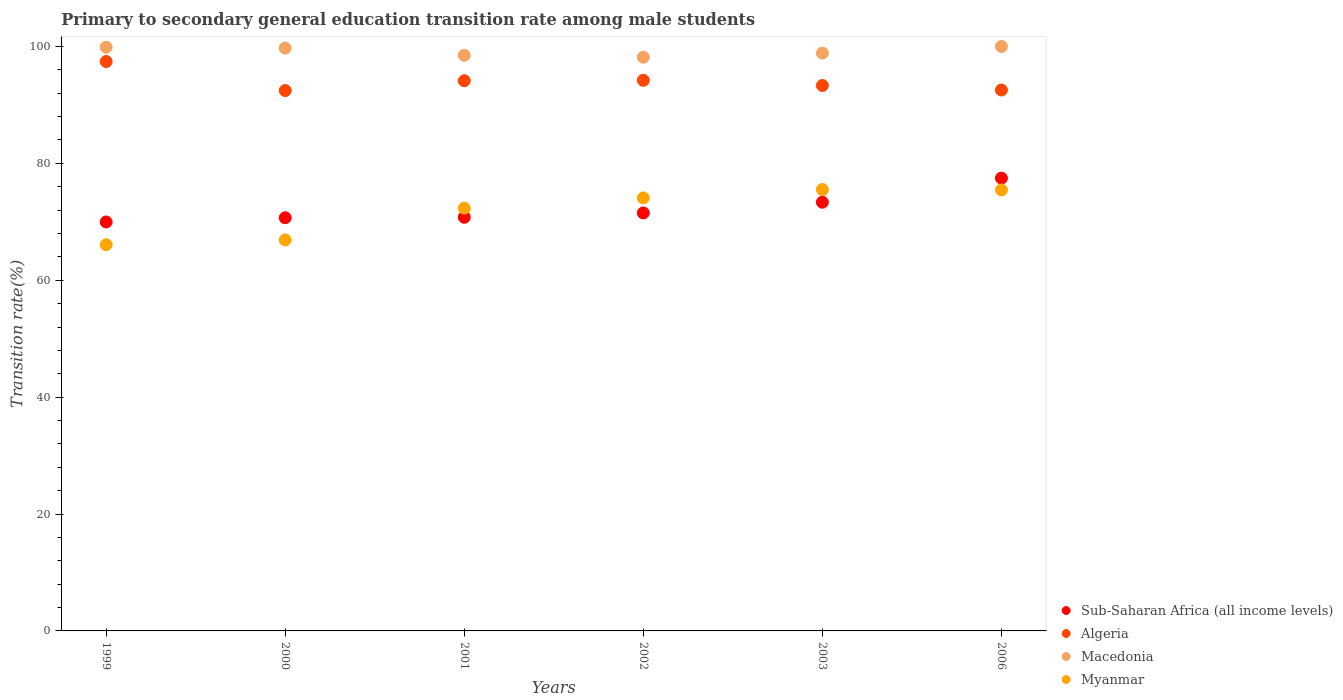Is the number of dotlines equal to the number of legend labels?
Keep it short and to the point. Yes. What is the transition rate in Algeria in 2000?
Ensure brevity in your answer.  92.46. Across all years, what is the maximum transition rate in Algeria?
Provide a succinct answer. 97.42. Across all years, what is the minimum transition rate in Algeria?
Provide a short and direct response. 92.46. What is the total transition rate in Myanmar in the graph?
Your answer should be compact. 430.37. What is the difference between the transition rate in Myanmar in 1999 and that in 2001?
Your answer should be compact. -6.25. What is the difference between the transition rate in Sub-Saharan Africa (all income levels) in 2006 and the transition rate in Myanmar in 2001?
Offer a terse response. 5.15. What is the average transition rate in Macedonia per year?
Provide a short and direct response. 99.19. In the year 2002, what is the difference between the transition rate in Macedonia and transition rate in Myanmar?
Keep it short and to the point. 24.08. What is the ratio of the transition rate in Macedonia in 2000 to that in 2003?
Ensure brevity in your answer.  1.01. Is the transition rate in Myanmar in 2001 less than that in 2002?
Your response must be concise. Yes. Is the difference between the transition rate in Macedonia in 1999 and 2003 greater than the difference between the transition rate in Myanmar in 1999 and 2003?
Offer a terse response. Yes. What is the difference between the highest and the second highest transition rate in Algeria?
Offer a very short reply. 3.21. What is the difference between the highest and the lowest transition rate in Myanmar?
Ensure brevity in your answer.  9.45. In how many years, is the transition rate in Macedonia greater than the average transition rate in Macedonia taken over all years?
Your answer should be very brief. 3. Is the sum of the transition rate in Macedonia in 2003 and 2006 greater than the maximum transition rate in Algeria across all years?
Your answer should be compact. Yes. Is the transition rate in Macedonia strictly greater than the transition rate in Myanmar over the years?
Make the answer very short. Yes. Is the transition rate in Myanmar strictly less than the transition rate in Macedonia over the years?
Offer a very short reply. Yes. Are the values on the major ticks of Y-axis written in scientific E-notation?
Your response must be concise. No. How many legend labels are there?
Offer a very short reply. 4. How are the legend labels stacked?
Ensure brevity in your answer.  Vertical. What is the title of the graph?
Keep it short and to the point. Primary to secondary general education transition rate among male students. What is the label or title of the Y-axis?
Give a very brief answer. Transition rate(%). What is the Transition rate(%) in Sub-Saharan Africa (all income levels) in 1999?
Your answer should be compact. 69.97. What is the Transition rate(%) of Algeria in 1999?
Your answer should be very brief. 97.42. What is the Transition rate(%) of Macedonia in 1999?
Your answer should be very brief. 99.87. What is the Transition rate(%) of Myanmar in 1999?
Your response must be concise. 66.07. What is the Transition rate(%) in Sub-Saharan Africa (all income levels) in 2000?
Your answer should be very brief. 70.7. What is the Transition rate(%) in Algeria in 2000?
Your answer should be very brief. 92.46. What is the Transition rate(%) in Macedonia in 2000?
Make the answer very short. 99.73. What is the Transition rate(%) of Myanmar in 2000?
Your answer should be compact. 66.9. What is the Transition rate(%) of Sub-Saharan Africa (all income levels) in 2001?
Give a very brief answer. 70.78. What is the Transition rate(%) in Algeria in 2001?
Provide a short and direct response. 94.14. What is the Transition rate(%) in Macedonia in 2001?
Ensure brevity in your answer.  98.49. What is the Transition rate(%) in Myanmar in 2001?
Your answer should be very brief. 72.33. What is the Transition rate(%) of Sub-Saharan Africa (all income levels) in 2002?
Your answer should be very brief. 71.52. What is the Transition rate(%) in Algeria in 2002?
Make the answer very short. 94.22. What is the Transition rate(%) of Macedonia in 2002?
Provide a succinct answer. 98.17. What is the Transition rate(%) in Myanmar in 2002?
Your answer should be very brief. 74.09. What is the Transition rate(%) in Sub-Saharan Africa (all income levels) in 2003?
Your answer should be very brief. 73.36. What is the Transition rate(%) of Algeria in 2003?
Ensure brevity in your answer.  93.33. What is the Transition rate(%) of Macedonia in 2003?
Keep it short and to the point. 98.87. What is the Transition rate(%) in Myanmar in 2003?
Make the answer very short. 75.52. What is the Transition rate(%) of Sub-Saharan Africa (all income levels) in 2006?
Provide a succinct answer. 77.47. What is the Transition rate(%) of Algeria in 2006?
Make the answer very short. 92.56. What is the Transition rate(%) of Myanmar in 2006?
Ensure brevity in your answer.  75.45. Across all years, what is the maximum Transition rate(%) of Sub-Saharan Africa (all income levels)?
Offer a very short reply. 77.47. Across all years, what is the maximum Transition rate(%) of Algeria?
Your answer should be very brief. 97.42. Across all years, what is the maximum Transition rate(%) of Macedonia?
Offer a terse response. 100. Across all years, what is the maximum Transition rate(%) of Myanmar?
Ensure brevity in your answer.  75.52. Across all years, what is the minimum Transition rate(%) in Sub-Saharan Africa (all income levels)?
Provide a short and direct response. 69.97. Across all years, what is the minimum Transition rate(%) of Algeria?
Provide a succinct answer. 92.46. Across all years, what is the minimum Transition rate(%) of Macedonia?
Provide a succinct answer. 98.17. Across all years, what is the minimum Transition rate(%) of Myanmar?
Make the answer very short. 66.07. What is the total Transition rate(%) in Sub-Saharan Africa (all income levels) in the graph?
Ensure brevity in your answer.  433.8. What is the total Transition rate(%) in Algeria in the graph?
Provide a short and direct response. 564.13. What is the total Transition rate(%) in Macedonia in the graph?
Keep it short and to the point. 595.13. What is the total Transition rate(%) of Myanmar in the graph?
Provide a short and direct response. 430.37. What is the difference between the Transition rate(%) in Sub-Saharan Africa (all income levels) in 1999 and that in 2000?
Ensure brevity in your answer.  -0.72. What is the difference between the Transition rate(%) of Algeria in 1999 and that in 2000?
Your answer should be very brief. 4.96. What is the difference between the Transition rate(%) of Macedonia in 1999 and that in 2000?
Offer a terse response. 0.15. What is the difference between the Transition rate(%) of Myanmar in 1999 and that in 2000?
Provide a succinct answer. -0.83. What is the difference between the Transition rate(%) in Sub-Saharan Africa (all income levels) in 1999 and that in 2001?
Provide a short and direct response. -0.8. What is the difference between the Transition rate(%) in Algeria in 1999 and that in 2001?
Offer a very short reply. 3.28. What is the difference between the Transition rate(%) of Macedonia in 1999 and that in 2001?
Your response must be concise. 1.38. What is the difference between the Transition rate(%) of Myanmar in 1999 and that in 2001?
Ensure brevity in your answer.  -6.25. What is the difference between the Transition rate(%) of Sub-Saharan Africa (all income levels) in 1999 and that in 2002?
Provide a short and direct response. -1.54. What is the difference between the Transition rate(%) of Algeria in 1999 and that in 2002?
Ensure brevity in your answer.  3.21. What is the difference between the Transition rate(%) in Macedonia in 1999 and that in 2002?
Give a very brief answer. 1.7. What is the difference between the Transition rate(%) in Myanmar in 1999 and that in 2002?
Give a very brief answer. -8.02. What is the difference between the Transition rate(%) in Sub-Saharan Africa (all income levels) in 1999 and that in 2003?
Provide a short and direct response. -3.38. What is the difference between the Transition rate(%) in Algeria in 1999 and that in 2003?
Your answer should be very brief. 4.1. What is the difference between the Transition rate(%) of Macedonia in 1999 and that in 2003?
Give a very brief answer. 1.01. What is the difference between the Transition rate(%) of Myanmar in 1999 and that in 2003?
Make the answer very short. -9.45. What is the difference between the Transition rate(%) of Sub-Saharan Africa (all income levels) in 1999 and that in 2006?
Provide a succinct answer. -7.5. What is the difference between the Transition rate(%) in Algeria in 1999 and that in 2006?
Give a very brief answer. 4.87. What is the difference between the Transition rate(%) of Macedonia in 1999 and that in 2006?
Give a very brief answer. -0.13. What is the difference between the Transition rate(%) of Myanmar in 1999 and that in 2006?
Ensure brevity in your answer.  -9.38. What is the difference between the Transition rate(%) in Sub-Saharan Africa (all income levels) in 2000 and that in 2001?
Provide a succinct answer. -0.08. What is the difference between the Transition rate(%) in Algeria in 2000 and that in 2001?
Your response must be concise. -1.68. What is the difference between the Transition rate(%) of Macedonia in 2000 and that in 2001?
Offer a very short reply. 1.24. What is the difference between the Transition rate(%) in Myanmar in 2000 and that in 2001?
Offer a very short reply. -5.43. What is the difference between the Transition rate(%) in Sub-Saharan Africa (all income levels) in 2000 and that in 2002?
Provide a succinct answer. -0.82. What is the difference between the Transition rate(%) in Algeria in 2000 and that in 2002?
Your answer should be compact. -1.75. What is the difference between the Transition rate(%) in Macedonia in 2000 and that in 2002?
Keep it short and to the point. 1.56. What is the difference between the Transition rate(%) in Myanmar in 2000 and that in 2002?
Offer a very short reply. -7.19. What is the difference between the Transition rate(%) of Sub-Saharan Africa (all income levels) in 2000 and that in 2003?
Ensure brevity in your answer.  -2.66. What is the difference between the Transition rate(%) of Algeria in 2000 and that in 2003?
Offer a terse response. -0.87. What is the difference between the Transition rate(%) of Macedonia in 2000 and that in 2003?
Make the answer very short. 0.86. What is the difference between the Transition rate(%) of Myanmar in 2000 and that in 2003?
Provide a short and direct response. -8.62. What is the difference between the Transition rate(%) in Sub-Saharan Africa (all income levels) in 2000 and that in 2006?
Provide a short and direct response. -6.78. What is the difference between the Transition rate(%) in Algeria in 2000 and that in 2006?
Keep it short and to the point. -0.1. What is the difference between the Transition rate(%) of Macedonia in 2000 and that in 2006?
Offer a very short reply. -0.27. What is the difference between the Transition rate(%) in Myanmar in 2000 and that in 2006?
Offer a terse response. -8.55. What is the difference between the Transition rate(%) of Sub-Saharan Africa (all income levels) in 2001 and that in 2002?
Provide a succinct answer. -0.74. What is the difference between the Transition rate(%) in Algeria in 2001 and that in 2002?
Your response must be concise. -0.07. What is the difference between the Transition rate(%) of Macedonia in 2001 and that in 2002?
Your response must be concise. 0.32. What is the difference between the Transition rate(%) of Myanmar in 2001 and that in 2002?
Give a very brief answer. -1.76. What is the difference between the Transition rate(%) of Sub-Saharan Africa (all income levels) in 2001 and that in 2003?
Make the answer very short. -2.58. What is the difference between the Transition rate(%) of Algeria in 2001 and that in 2003?
Keep it short and to the point. 0.81. What is the difference between the Transition rate(%) of Macedonia in 2001 and that in 2003?
Offer a very short reply. -0.37. What is the difference between the Transition rate(%) in Myanmar in 2001 and that in 2003?
Ensure brevity in your answer.  -3.19. What is the difference between the Transition rate(%) in Sub-Saharan Africa (all income levels) in 2001 and that in 2006?
Your response must be concise. -6.7. What is the difference between the Transition rate(%) of Algeria in 2001 and that in 2006?
Provide a succinct answer. 1.58. What is the difference between the Transition rate(%) of Macedonia in 2001 and that in 2006?
Give a very brief answer. -1.51. What is the difference between the Transition rate(%) in Myanmar in 2001 and that in 2006?
Provide a succinct answer. -3.12. What is the difference between the Transition rate(%) in Sub-Saharan Africa (all income levels) in 2002 and that in 2003?
Offer a very short reply. -1.84. What is the difference between the Transition rate(%) in Algeria in 2002 and that in 2003?
Your answer should be very brief. 0.89. What is the difference between the Transition rate(%) of Macedonia in 2002 and that in 2003?
Your response must be concise. -0.7. What is the difference between the Transition rate(%) of Myanmar in 2002 and that in 2003?
Provide a succinct answer. -1.43. What is the difference between the Transition rate(%) of Sub-Saharan Africa (all income levels) in 2002 and that in 2006?
Offer a very short reply. -5.96. What is the difference between the Transition rate(%) in Algeria in 2002 and that in 2006?
Your answer should be compact. 1.66. What is the difference between the Transition rate(%) in Macedonia in 2002 and that in 2006?
Your answer should be compact. -1.83. What is the difference between the Transition rate(%) in Myanmar in 2002 and that in 2006?
Your answer should be very brief. -1.36. What is the difference between the Transition rate(%) in Sub-Saharan Africa (all income levels) in 2003 and that in 2006?
Ensure brevity in your answer.  -4.12. What is the difference between the Transition rate(%) in Algeria in 2003 and that in 2006?
Offer a very short reply. 0.77. What is the difference between the Transition rate(%) in Macedonia in 2003 and that in 2006?
Your response must be concise. -1.13. What is the difference between the Transition rate(%) of Myanmar in 2003 and that in 2006?
Offer a very short reply. 0.07. What is the difference between the Transition rate(%) in Sub-Saharan Africa (all income levels) in 1999 and the Transition rate(%) in Algeria in 2000?
Offer a very short reply. -22.49. What is the difference between the Transition rate(%) of Sub-Saharan Africa (all income levels) in 1999 and the Transition rate(%) of Macedonia in 2000?
Offer a very short reply. -29.75. What is the difference between the Transition rate(%) in Sub-Saharan Africa (all income levels) in 1999 and the Transition rate(%) in Myanmar in 2000?
Keep it short and to the point. 3.07. What is the difference between the Transition rate(%) in Algeria in 1999 and the Transition rate(%) in Macedonia in 2000?
Provide a short and direct response. -2.3. What is the difference between the Transition rate(%) of Algeria in 1999 and the Transition rate(%) of Myanmar in 2000?
Provide a short and direct response. 30.52. What is the difference between the Transition rate(%) in Macedonia in 1999 and the Transition rate(%) in Myanmar in 2000?
Offer a terse response. 32.97. What is the difference between the Transition rate(%) in Sub-Saharan Africa (all income levels) in 1999 and the Transition rate(%) in Algeria in 2001?
Provide a succinct answer. -24.17. What is the difference between the Transition rate(%) in Sub-Saharan Africa (all income levels) in 1999 and the Transition rate(%) in Macedonia in 2001?
Your answer should be very brief. -28.52. What is the difference between the Transition rate(%) in Sub-Saharan Africa (all income levels) in 1999 and the Transition rate(%) in Myanmar in 2001?
Your response must be concise. -2.35. What is the difference between the Transition rate(%) in Algeria in 1999 and the Transition rate(%) in Macedonia in 2001?
Offer a very short reply. -1.07. What is the difference between the Transition rate(%) of Algeria in 1999 and the Transition rate(%) of Myanmar in 2001?
Give a very brief answer. 25.1. What is the difference between the Transition rate(%) in Macedonia in 1999 and the Transition rate(%) in Myanmar in 2001?
Keep it short and to the point. 27.55. What is the difference between the Transition rate(%) in Sub-Saharan Africa (all income levels) in 1999 and the Transition rate(%) in Algeria in 2002?
Your response must be concise. -24.24. What is the difference between the Transition rate(%) of Sub-Saharan Africa (all income levels) in 1999 and the Transition rate(%) of Macedonia in 2002?
Keep it short and to the point. -28.2. What is the difference between the Transition rate(%) in Sub-Saharan Africa (all income levels) in 1999 and the Transition rate(%) in Myanmar in 2002?
Your answer should be very brief. -4.12. What is the difference between the Transition rate(%) in Algeria in 1999 and the Transition rate(%) in Macedonia in 2002?
Ensure brevity in your answer.  -0.75. What is the difference between the Transition rate(%) in Algeria in 1999 and the Transition rate(%) in Myanmar in 2002?
Give a very brief answer. 23.33. What is the difference between the Transition rate(%) of Macedonia in 1999 and the Transition rate(%) of Myanmar in 2002?
Keep it short and to the point. 25.78. What is the difference between the Transition rate(%) of Sub-Saharan Africa (all income levels) in 1999 and the Transition rate(%) of Algeria in 2003?
Ensure brevity in your answer.  -23.35. What is the difference between the Transition rate(%) in Sub-Saharan Africa (all income levels) in 1999 and the Transition rate(%) in Macedonia in 2003?
Provide a succinct answer. -28.89. What is the difference between the Transition rate(%) in Sub-Saharan Africa (all income levels) in 1999 and the Transition rate(%) in Myanmar in 2003?
Your answer should be compact. -5.55. What is the difference between the Transition rate(%) in Algeria in 1999 and the Transition rate(%) in Macedonia in 2003?
Provide a short and direct response. -1.44. What is the difference between the Transition rate(%) of Algeria in 1999 and the Transition rate(%) of Myanmar in 2003?
Your answer should be very brief. 21.9. What is the difference between the Transition rate(%) of Macedonia in 1999 and the Transition rate(%) of Myanmar in 2003?
Your answer should be compact. 24.35. What is the difference between the Transition rate(%) in Sub-Saharan Africa (all income levels) in 1999 and the Transition rate(%) in Algeria in 2006?
Keep it short and to the point. -22.58. What is the difference between the Transition rate(%) of Sub-Saharan Africa (all income levels) in 1999 and the Transition rate(%) of Macedonia in 2006?
Offer a terse response. -30.03. What is the difference between the Transition rate(%) in Sub-Saharan Africa (all income levels) in 1999 and the Transition rate(%) in Myanmar in 2006?
Ensure brevity in your answer.  -5.48. What is the difference between the Transition rate(%) of Algeria in 1999 and the Transition rate(%) of Macedonia in 2006?
Your answer should be very brief. -2.58. What is the difference between the Transition rate(%) of Algeria in 1999 and the Transition rate(%) of Myanmar in 2006?
Offer a terse response. 21.97. What is the difference between the Transition rate(%) of Macedonia in 1999 and the Transition rate(%) of Myanmar in 2006?
Your response must be concise. 24.42. What is the difference between the Transition rate(%) in Sub-Saharan Africa (all income levels) in 2000 and the Transition rate(%) in Algeria in 2001?
Provide a succinct answer. -23.44. What is the difference between the Transition rate(%) of Sub-Saharan Africa (all income levels) in 2000 and the Transition rate(%) of Macedonia in 2001?
Ensure brevity in your answer.  -27.79. What is the difference between the Transition rate(%) in Sub-Saharan Africa (all income levels) in 2000 and the Transition rate(%) in Myanmar in 2001?
Offer a terse response. -1.63. What is the difference between the Transition rate(%) of Algeria in 2000 and the Transition rate(%) of Macedonia in 2001?
Your answer should be very brief. -6.03. What is the difference between the Transition rate(%) of Algeria in 2000 and the Transition rate(%) of Myanmar in 2001?
Ensure brevity in your answer.  20.13. What is the difference between the Transition rate(%) of Macedonia in 2000 and the Transition rate(%) of Myanmar in 2001?
Give a very brief answer. 27.4. What is the difference between the Transition rate(%) in Sub-Saharan Africa (all income levels) in 2000 and the Transition rate(%) in Algeria in 2002?
Offer a very short reply. -23.52. What is the difference between the Transition rate(%) of Sub-Saharan Africa (all income levels) in 2000 and the Transition rate(%) of Macedonia in 2002?
Give a very brief answer. -27.47. What is the difference between the Transition rate(%) in Sub-Saharan Africa (all income levels) in 2000 and the Transition rate(%) in Myanmar in 2002?
Give a very brief answer. -3.39. What is the difference between the Transition rate(%) in Algeria in 2000 and the Transition rate(%) in Macedonia in 2002?
Offer a terse response. -5.71. What is the difference between the Transition rate(%) in Algeria in 2000 and the Transition rate(%) in Myanmar in 2002?
Ensure brevity in your answer.  18.37. What is the difference between the Transition rate(%) of Macedonia in 2000 and the Transition rate(%) of Myanmar in 2002?
Your response must be concise. 25.64. What is the difference between the Transition rate(%) in Sub-Saharan Africa (all income levels) in 2000 and the Transition rate(%) in Algeria in 2003?
Provide a succinct answer. -22.63. What is the difference between the Transition rate(%) in Sub-Saharan Africa (all income levels) in 2000 and the Transition rate(%) in Macedonia in 2003?
Provide a succinct answer. -28.17. What is the difference between the Transition rate(%) of Sub-Saharan Africa (all income levels) in 2000 and the Transition rate(%) of Myanmar in 2003?
Provide a succinct answer. -4.83. What is the difference between the Transition rate(%) of Algeria in 2000 and the Transition rate(%) of Macedonia in 2003?
Offer a terse response. -6.4. What is the difference between the Transition rate(%) in Algeria in 2000 and the Transition rate(%) in Myanmar in 2003?
Your response must be concise. 16.94. What is the difference between the Transition rate(%) in Macedonia in 2000 and the Transition rate(%) in Myanmar in 2003?
Your answer should be compact. 24.2. What is the difference between the Transition rate(%) of Sub-Saharan Africa (all income levels) in 2000 and the Transition rate(%) of Algeria in 2006?
Provide a short and direct response. -21.86. What is the difference between the Transition rate(%) of Sub-Saharan Africa (all income levels) in 2000 and the Transition rate(%) of Macedonia in 2006?
Give a very brief answer. -29.3. What is the difference between the Transition rate(%) in Sub-Saharan Africa (all income levels) in 2000 and the Transition rate(%) in Myanmar in 2006?
Ensure brevity in your answer.  -4.75. What is the difference between the Transition rate(%) in Algeria in 2000 and the Transition rate(%) in Macedonia in 2006?
Offer a terse response. -7.54. What is the difference between the Transition rate(%) in Algeria in 2000 and the Transition rate(%) in Myanmar in 2006?
Keep it short and to the point. 17.01. What is the difference between the Transition rate(%) of Macedonia in 2000 and the Transition rate(%) of Myanmar in 2006?
Offer a very short reply. 24.28. What is the difference between the Transition rate(%) of Sub-Saharan Africa (all income levels) in 2001 and the Transition rate(%) of Algeria in 2002?
Your answer should be very brief. -23.44. What is the difference between the Transition rate(%) in Sub-Saharan Africa (all income levels) in 2001 and the Transition rate(%) in Macedonia in 2002?
Your response must be concise. -27.39. What is the difference between the Transition rate(%) in Sub-Saharan Africa (all income levels) in 2001 and the Transition rate(%) in Myanmar in 2002?
Give a very brief answer. -3.31. What is the difference between the Transition rate(%) in Algeria in 2001 and the Transition rate(%) in Macedonia in 2002?
Keep it short and to the point. -4.03. What is the difference between the Transition rate(%) of Algeria in 2001 and the Transition rate(%) of Myanmar in 2002?
Offer a terse response. 20.05. What is the difference between the Transition rate(%) in Macedonia in 2001 and the Transition rate(%) in Myanmar in 2002?
Ensure brevity in your answer.  24.4. What is the difference between the Transition rate(%) in Sub-Saharan Africa (all income levels) in 2001 and the Transition rate(%) in Algeria in 2003?
Your answer should be very brief. -22.55. What is the difference between the Transition rate(%) of Sub-Saharan Africa (all income levels) in 2001 and the Transition rate(%) of Macedonia in 2003?
Your response must be concise. -28.09. What is the difference between the Transition rate(%) of Sub-Saharan Africa (all income levels) in 2001 and the Transition rate(%) of Myanmar in 2003?
Your answer should be compact. -4.74. What is the difference between the Transition rate(%) in Algeria in 2001 and the Transition rate(%) in Macedonia in 2003?
Your response must be concise. -4.72. What is the difference between the Transition rate(%) in Algeria in 2001 and the Transition rate(%) in Myanmar in 2003?
Offer a very short reply. 18.62. What is the difference between the Transition rate(%) of Macedonia in 2001 and the Transition rate(%) of Myanmar in 2003?
Make the answer very short. 22.97. What is the difference between the Transition rate(%) in Sub-Saharan Africa (all income levels) in 2001 and the Transition rate(%) in Algeria in 2006?
Provide a succinct answer. -21.78. What is the difference between the Transition rate(%) of Sub-Saharan Africa (all income levels) in 2001 and the Transition rate(%) of Macedonia in 2006?
Provide a succinct answer. -29.22. What is the difference between the Transition rate(%) in Sub-Saharan Africa (all income levels) in 2001 and the Transition rate(%) in Myanmar in 2006?
Offer a very short reply. -4.67. What is the difference between the Transition rate(%) of Algeria in 2001 and the Transition rate(%) of Macedonia in 2006?
Your response must be concise. -5.86. What is the difference between the Transition rate(%) of Algeria in 2001 and the Transition rate(%) of Myanmar in 2006?
Offer a very short reply. 18.69. What is the difference between the Transition rate(%) of Macedonia in 2001 and the Transition rate(%) of Myanmar in 2006?
Your answer should be very brief. 23.04. What is the difference between the Transition rate(%) in Sub-Saharan Africa (all income levels) in 2002 and the Transition rate(%) in Algeria in 2003?
Ensure brevity in your answer.  -21.81. What is the difference between the Transition rate(%) of Sub-Saharan Africa (all income levels) in 2002 and the Transition rate(%) of Macedonia in 2003?
Offer a very short reply. -27.35. What is the difference between the Transition rate(%) in Sub-Saharan Africa (all income levels) in 2002 and the Transition rate(%) in Myanmar in 2003?
Give a very brief answer. -4. What is the difference between the Transition rate(%) in Algeria in 2002 and the Transition rate(%) in Macedonia in 2003?
Ensure brevity in your answer.  -4.65. What is the difference between the Transition rate(%) in Algeria in 2002 and the Transition rate(%) in Myanmar in 2003?
Offer a very short reply. 18.69. What is the difference between the Transition rate(%) in Macedonia in 2002 and the Transition rate(%) in Myanmar in 2003?
Ensure brevity in your answer.  22.65. What is the difference between the Transition rate(%) of Sub-Saharan Africa (all income levels) in 2002 and the Transition rate(%) of Algeria in 2006?
Keep it short and to the point. -21.04. What is the difference between the Transition rate(%) of Sub-Saharan Africa (all income levels) in 2002 and the Transition rate(%) of Macedonia in 2006?
Keep it short and to the point. -28.48. What is the difference between the Transition rate(%) of Sub-Saharan Africa (all income levels) in 2002 and the Transition rate(%) of Myanmar in 2006?
Ensure brevity in your answer.  -3.93. What is the difference between the Transition rate(%) of Algeria in 2002 and the Transition rate(%) of Macedonia in 2006?
Give a very brief answer. -5.78. What is the difference between the Transition rate(%) in Algeria in 2002 and the Transition rate(%) in Myanmar in 2006?
Your answer should be compact. 18.77. What is the difference between the Transition rate(%) in Macedonia in 2002 and the Transition rate(%) in Myanmar in 2006?
Provide a succinct answer. 22.72. What is the difference between the Transition rate(%) in Sub-Saharan Africa (all income levels) in 2003 and the Transition rate(%) in Algeria in 2006?
Provide a succinct answer. -19.2. What is the difference between the Transition rate(%) of Sub-Saharan Africa (all income levels) in 2003 and the Transition rate(%) of Macedonia in 2006?
Your answer should be very brief. -26.64. What is the difference between the Transition rate(%) in Sub-Saharan Africa (all income levels) in 2003 and the Transition rate(%) in Myanmar in 2006?
Make the answer very short. -2.09. What is the difference between the Transition rate(%) of Algeria in 2003 and the Transition rate(%) of Macedonia in 2006?
Offer a terse response. -6.67. What is the difference between the Transition rate(%) of Algeria in 2003 and the Transition rate(%) of Myanmar in 2006?
Offer a very short reply. 17.88. What is the difference between the Transition rate(%) of Macedonia in 2003 and the Transition rate(%) of Myanmar in 2006?
Your response must be concise. 23.42. What is the average Transition rate(%) of Sub-Saharan Africa (all income levels) per year?
Ensure brevity in your answer.  72.3. What is the average Transition rate(%) of Algeria per year?
Ensure brevity in your answer.  94.02. What is the average Transition rate(%) in Macedonia per year?
Give a very brief answer. 99.19. What is the average Transition rate(%) in Myanmar per year?
Keep it short and to the point. 71.73. In the year 1999, what is the difference between the Transition rate(%) in Sub-Saharan Africa (all income levels) and Transition rate(%) in Algeria?
Offer a very short reply. -27.45. In the year 1999, what is the difference between the Transition rate(%) of Sub-Saharan Africa (all income levels) and Transition rate(%) of Macedonia?
Keep it short and to the point. -29.9. In the year 1999, what is the difference between the Transition rate(%) of Sub-Saharan Africa (all income levels) and Transition rate(%) of Myanmar?
Provide a succinct answer. 3.9. In the year 1999, what is the difference between the Transition rate(%) of Algeria and Transition rate(%) of Macedonia?
Ensure brevity in your answer.  -2.45. In the year 1999, what is the difference between the Transition rate(%) of Algeria and Transition rate(%) of Myanmar?
Make the answer very short. 31.35. In the year 1999, what is the difference between the Transition rate(%) in Macedonia and Transition rate(%) in Myanmar?
Provide a short and direct response. 33.8. In the year 2000, what is the difference between the Transition rate(%) in Sub-Saharan Africa (all income levels) and Transition rate(%) in Algeria?
Give a very brief answer. -21.76. In the year 2000, what is the difference between the Transition rate(%) of Sub-Saharan Africa (all income levels) and Transition rate(%) of Macedonia?
Your response must be concise. -29.03. In the year 2000, what is the difference between the Transition rate(%) in Sub-Saharan Africa (all income levels) and Transition rate(%) in Myanmar?
Provide a short and direct response. 3.8. In the year 2000, what is the difference between the Transition rate(%) of Algeria and Transition rate(%) of Macedonia?
Your answer should be compact. -7.27. In the year 2000, what is the difference between the Transition rate(%) in Algeria and Transition rate(%) in Myanmar?
Provide a short and direct response. 25.56. In the year 2000, what is the difference between the Transition rate(%) in Macedonia and Transition rate(%) in Myanmar?
Provide a short and direct response. 32.83. In the year 2001, what is the difference between the Transition rate(%) in Sub-Saharan Africa (all income levels) and Transition rate(%) in Algeria?
Offer a terse response. -23.36. In the year 2001, what is the difference between the Transition rate(%) of Sub-Saharan Africa (all income levels) and Transition rate(%) of Macedonia?
Offer a terse response. -27.71. In the year 2001, what is the difference between the Transition rate(%) of Sub-Saharan Africa (all income levels) and Transition rate(%) of Myanmar?
Ensure brevity in your answer.  -1.55. In the year 2001, what is the difference between the Transition rate(%) in Algeria and Transition rate(%) in Macedonia?
Keep it short and to the point. -4.35. In the year 2001, what is the difference between the Transition rate(%) of Algeria and Transition rate(%) of Myanmar?
Offer a very short reply. 21.81. In the year 2001, what is the difference between the Transition rate(%) in Macedonia and Transition rate(%) in Myanmar?
Offer a very short reply. 26.16. In the year 2002, what is the difference between the Transition rate(%) in Sub-Saharan Africa (all income levels) and Transition rate(%) in Algeria?
Offer a terse response. -22.7. In the year 2002, what is the difference between the Transition rate(%) in Sub-Saharan Africa (all income levels) and Transition rate(%) in Macedonia?
Keep it short and to the point. -26.65. In the year 2002, what is the difference between the Transition rate(%) of Sub-Saharan Africa (all income levels) and Transition rate(%) of Myanmar?
Give a very brief answer. -2.57. In the year 2002, what is the difference between the Transition rate(%) in Algeria and Transition rate(%) in Macedonia?
Provide a short and direct response. -3.96. In the year 2002, what is the difference between the Transition rate(%) in Algeria and Transition rate(%) in Myanmar?
Provide a short and direct response. 20.12. In the year 2002, what is the difference between the Transition rate(%) of Macedonia and Transition rate(%) of Myanmar?
Make the answer very short. 24.08. In the year 2003, what is the difference between the Transition rate(%) in Sub-Saharan Africa (all income levels) and Transition rate(%) in Algeria?
Your answer should be compact. -19.97. In the year 2003, what is the difference between the Transition rate(%) in Sub-Saharan Africa (all income levels) and Transition rate(%) in Macedonia?
Ensure brevity in your answer.  -25.51. In the year 2003, what is the difference between the Transition rate(%) in Sub-Saharan Africa (all income levels) and Transition rate(%) in Myanmar?
Ensure brevity in your answer.  -2.17. In the year 2003, what is the difference between the Transition rate(%) of Algeria and Transition rate(%) of Macedonia?
Offer a terse response. -5.54. In the year 2003, what is the difference between the Transition rate(%) in Algeria and Transition rate(%) in Myanmar?
Provide a short and direct response. 17.8. In the year 2003, what is the difference between the Transition rate(%) of Macedonia and Transition rate(%) of Myanmar?
Make the answer very short. 23.34. In the year 2006, what is the difference between the Transition rate(%) of Sub-Saharan Africa (all income levels) and Transition rate(%) of Algeria?
Make the answer very short. -15.08. In the year 2006, what is the difference between the Transition rate(%) of Sub-Saharan Africa (all income levels) and Transition rate(%) of Macedonia?
Your answer should be very brief. -22.53. In the year 2006, what is the difference between the Transition rate(%) of Sub-Saharan Africa (all income levels) and Transition rate(%) of Myanmar?
Your answer should be very brief. 2.02. In the year 2006, what is the difference between the Transition rate(%) of Algeria and Transition rate(%) of Macedonia?
Your answer should be very brief. -7.44. In the year 2006, what is the difference between the Transition rate(%) of Algeria and Transition rate(%) of Myanmar?
Your answer should be very brief. 17.11. In the year 2006, what is the difference between the Transition rate(%) in Macedonia and Transition rate(%) in Myanmar?
Your response must be concise. 24.55. What is the ratio of the Transition rate(%) of Sub-Saharan Africa (all income levels) in 1999 to that in 2000?
Make the answer very short. 0.99. What is the ratio of the Transition rate(%) in Algeria in 1999 to that in 2000?
Make the answer very short. 1.05. What is the ratio of the Transition rate(%) of Macedonia in 1999 to that in 2000?
Your answer should be very brief. 1. What is the ratio of the Transition rate(%) of Myanmar in 1999 to that in 2000?
Provide a short and direct response. 0.99. What is the ratio of the Transition rate(%) in Sub-Saharan Africa (all income levels) in 1999 to that in 2001?
Provide a short and direct response. 0.99. What is the ratio of the Transition rate(%) of Algeria in 1999 to that in 2001?
Your answer should be compact. 1.03. What is the ratio of the Transition rate(%) of Myanmar in 1999 to that in 2001?
Your response must be concise. 0.91. What is the ratio of the Transition rate(%) in Sub-Saharan Africa (all income levels) in 1999 to that in 2002?
Ensure brevity in your answer.  0.98. What is the ratio of the Transition rate(%) of Algeria in 1999 to that in 2002?
Make the answer very short. 1.03. What is the ratio of the Transition rate(%) of Macedonia in 1999 to that in 2002?
Offer a terse response. 1.02. What is the ratio of the Transition rate(%) of Myanmar in 1999 to that in 2002?
Offer a very short reply. 0.89. What is the ratio of the Transition rate(%) in Sub-Saharan Africa (all income levels) in 1999 to that in 2003?
Ensure brevity in your answer.  0.95. What is the ratio of the Transition rate(%) of Algeria in 1999 to that in 2003?
Provide a succinct answer. 1.04. What is the ratio of the Transition rate(%) in Macedonia in 1999 to that in 2003?
Your answer should be very brief. 1.01. What is the ratio of the Transition rate(%) in Myanmar in 1999 to that in 2003?
Make the answer very short. 0.87. What is the ratio of the Transition rate(%) of Sub-Saharan Africa (all income levels) in 1999 to that in 2006?
Give a very brief answer. 0.9. What is the ratio of the Transition rate(%) of Algeria in 1999 to that in 2006?
Your response must be concise. 1.05. What is the ratio of the Transition rate(%) of Macedonia in 1999 to that in 2006?
Your answer should be compact. 1. What is the ratio of the Transition rate(%) of Myanmar in 1999 to that in 2006?
Your answer should be very brief. 0.88. What is the ratio of the Transition rate(%) in Sub-Saharan Africa (all income levels) in 2000 to that in 2001?
Offer a very short reply. 1. What is the ratio of the Transition rate(%) in Algeria in 2000 to that in 2001?
Your response must be concise. 0.98. What is the ratio of the Transition rate(%) of Macedonia in 2000 to that in 2001?
Offer a terse response. 1.01. What is the ratio of the Transition rate(%) of Myanmar in 2000 to that in 2001?
Keep it short and to the point. 0.93. What is the ratio of the Transition rate(%) in Sub-Saharan Africa (all income levels) in 2000 to that in 2002?
Provide a succinct answer. 0.99. What is the ratio of the Transition rate(%) of Algeria in 2000 to that in 2002?
Give a very brief answer. 0.98. What is the ratio of the Transition rate(%) in Macedonia in 2000 to that in 2002?
Ensure brevity in your answer.  1.02. What is the ratio of the Transition rate(%) of Myanmar in 2000 to that in 2002?
Provide a short and direct response. 0.9. What is the ratio of the Transition rate(%) of Sub-Saharan Africa (all income levels) in 2000 to that in 2003?
Offer a very short reply. 0.96. What is the ratio of the Transition rate(%) in Macedonia in 2000 to that in 2003?
Offer a terse response. 1.01. What is the ratio of the Transition rate(%) of Myanmar in 2000 to that in 2003?
Offer a very short reply. 0.89. What is the ratio of the Transition rate(%) in Sub-Saharan Africa (all income levels) in 2000 to that in 2006?
Provide a succinct answer. 0.91. What is the ratio of the Transition rate(%) of Macedonia in 2000 to that in 2006?
Provide a short and direct response. 1. What is the ratio of the Transition rate(%) in Myanmar in 2000 to that in 2006?
Offer a very short reply. 0.89. What is the ratio of the Transition rate(%) in Myanmar in 2001 to that in 2002?
Make the answer very short. 0.98. What is the ratio of the Transition rate(%) in Sub-Saharan Africa (all income levels) in 2001 to that in 2003?
Your answer should be very brief. 0.96. What is the ratio of the Transition rate(%) in Algeria in 2001 to that in 2003?
Make the answer very short. 1.01. What is the ratio of the Transition rate(%) of Myanmar in 2001 to that in 2003?
Your answer should be very brief. 0.96. What is the ratio of the Transition rate(%) in Sub-Saharan Africa (all income levels) in 2001 to that in 2006?
Your answer should be very brief. 0.91. What is the ratio of the Transition rate(%) of Algeria in 2001 to that in 2006?
Your response must be concise. 1.02. What is the ratio of the Transition rate(%) in Macedonia in 2001 to that in 2006?
Provide a short and direct response. 0.98. What is the ratio of the Transition rate(%) of Myanmar in 2001 to that in 2006?
Your answer should be very brief. 0.96. What is the ratio of the Transition rate(%) of Sub-Saharan Africa (all income levels) in 2002 to that in 2003?
Provide a short and direct response. 0.97. What is the ratio of the Transition rate(%) in Algeria in 2002 to that in 2003?
Offer a terse response. 1.01. What is the ratio of the Transition rate(%) in Macedonia in 2002 to that in 2003?
Offer a very short reply. 0.99. What is the ratio of the Transition rate(%) of Myanmar in 2002 to that in 2003?
Provide a short and direct response. 0.98. What is the ratio of the Transition rate(%) of Sub-Saharan Africa (all income levels) in 2002 to that in 2006?
Your response must be concise. 0.92. What is the ratio of the Transition rate(%) of Algeria in 2002 to that in 2006?
Give a very brief answer. 1.02. What is the ratio of the Transition rate(%) in Macedonia in 2002 to that in 2006?
Ensure brevity in your answer.  0.98. What is the ratio of the Transition rate(%) in Sub-Saharan Africa (all income levels) in 2003 to that in 2006?
Keep it short and to the point. 0.95. What is the ratio of the Transition rate(%) in Algeria in 2003 to that in 2006?
Offer a terse response. 1.01. What is the ratio of the Transition rate(%) in Macedonia in 2003 to that in 2006?
Offer a terse response. 0.99. What is the ratio of the Transition rate(%) of Myanmar in 2003 to that in 2006?
Provide a succinct answer. 1. What is the difference between the highest and the second highest Transition rate(%) of Sub-Saharan Africa (all income levels)?
Your response must be concise. 4.12. What is the difference between the highest and the second highest Transition rate(%) in Algeria?
Make the answer very short. 3.21. What is the difference between the highest and the second highest Transition rate(%) of Macedonia?
Offer a terse response. 0.13. What is the difference between the highest and the second highest Transition rate(%) of Myanmar?
Provide a succinct answer. 0.07. What is the difference between the highest and the lowest Transition rate(%) of Sub-Saharan Africa (all income levels)?
Ensure brevity in your answer.  7.5. What is the difference between the highest and the lowest Transition rate(%) of Algeria?
Make the answer very short. 4.96. What is the difference between the highest and the lowest Transition rate(%) of Macedonia?
Give a very brief answer. 1.83. What is the difference between the highest and the lowest Transition rate(%) of Myanmar?
Provide a short and direct response. 9.45. 